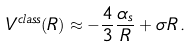<formula> <loc_0><loc_0><loc_500><loc_500>V ^ { c l a s s } ( R ) \approx - \frac { 4 } { 3 } \frac { \alpha _ { s } } { R } + \sigma R \, .</formula> 